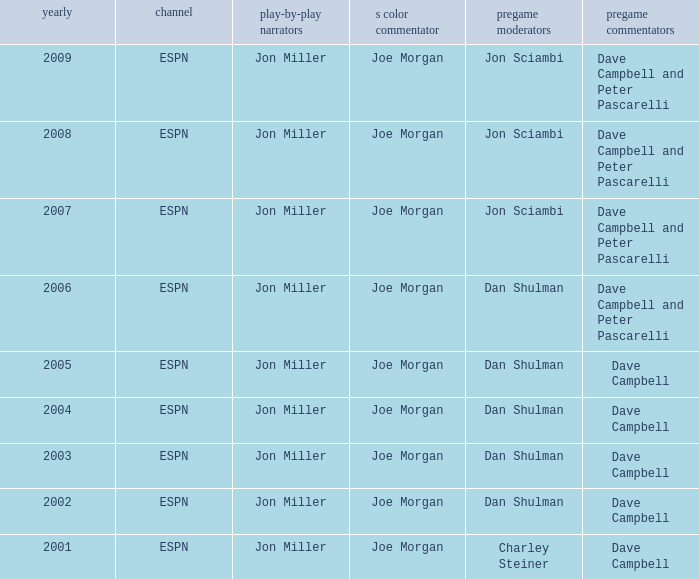How many networks are listed when the year is 2008? 1.0. Would you be able to parse every entry in this table? {'header': ['yearly', 'channel', 'play-by-play narrators', 's color commentator', 'pregame moderators', 'pregame commentators'], 'rows': [['2009', 'ESPN', 'Jon Miller', 'Joe Morgan', 'Jon Sciambi', 'Dave Campbell and Peter Pascarelli'], ['2008', 'ESPN', 'Jon Miller', 'Joe Morgan', 'Jon Sciambi', 'Dave Campbell and Peter Pascarelli'], ['2007', 'ESPN', 'Jon Miller', 'Joe Morgan', 'Jon Sciambi', 'Dave Campbell and Peter Pascarelli'], ['2006', 'ESPN', 'Jon Miller', 'Joe Morgan', 'Dan Shulman', 'Dave Campbell and Peter Pascarelli'], ['2005', 'ESPN', 'Jon Miller', 'Joe Morgan', 'Dan Shulman', 'Dave Campbell'], ['2004', 'ESPN', 'Jon Miller', 'Joe Morgan', 'Dan Shulman', 'Dave Campbell'], ['2003', 'ESPN', 'Jon Miller', 'Joe Morgan', 'Dan Shulman', 'Dave Campbell'], ['2002', 'ESPN', 'Jon Miller', 'Joe Morgan', 'Dan Shulman', 'Dave Campbell'], ['2001', 'ESPN', 'Jon Miller', 'Joe Morgan', 'Charley Steiner', 'Dave Campbell']]} 